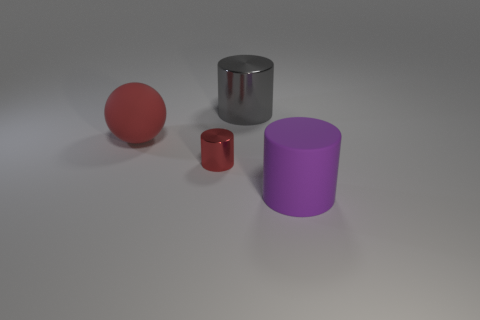Is there a big cube of the same color as the big metallic thing?
Make the answer very short. No. Are there fewer small yellow cylinders than big matte things?
Your answer should be very brief. Yes. What number of things are big brown blocks or large rubber things on the left side of the big shiny thing?
Give a very brief answer. 1. Are there any big gray objects made of the same material as the big ball?
Your answer should be compact. No. There is a red object that is the same size as the matte cylinder; what material is it?
Offer a terse response. Rubber. What is the material of the large thing that is left of the metallic cylinder to the right of the tiny red shiny thing?
Make the answer very short. Rubber. Does the matte thing behind the small metal cylinder have the same shape as the gray object?
Give a very brief answer. No. There is another thing that is made of the same material as the purple object; what is its color?
Offer a terse response. Red. What is the material of the big cylinder that is behind the big purple rubber cylinder?
Give a very brief answer. Metal. There is a big gray thing; is it the same shape as the large matte object that is to the right of the gray cylinder?
Your response must be concise. Yes. 